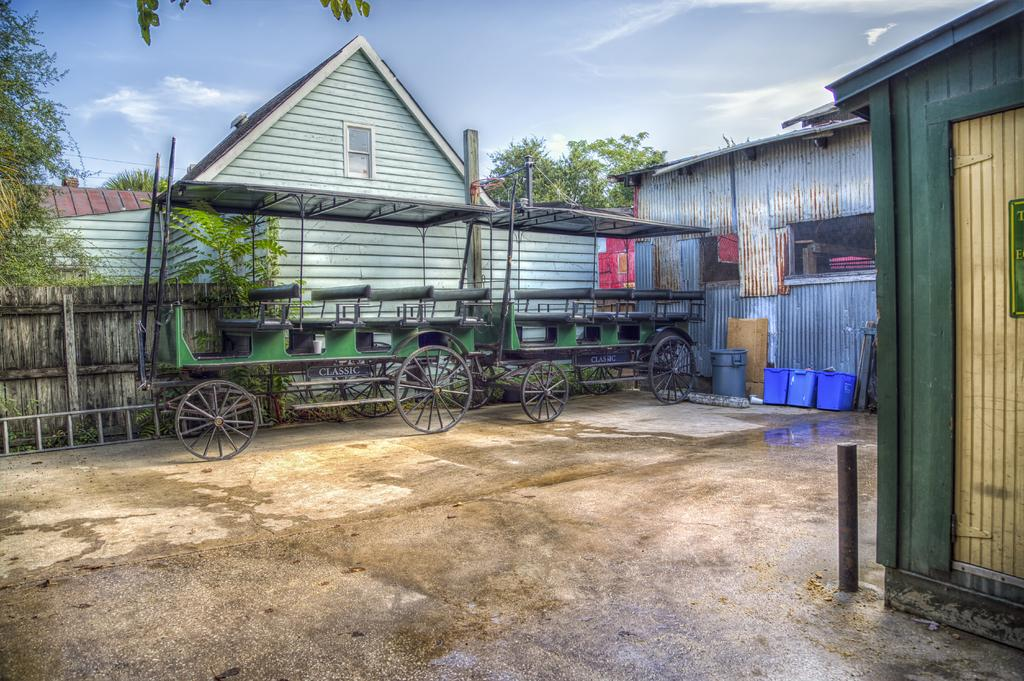What objects are on the floor in the image? There are vehicles on the floor in the image. What feature do the vehicles have? The vehicles have buckets. What is the purpose of the dustbin in the image? The dustbin is likely used for waste disposal. What can be seen on the left side of the image? There is a fence on the left side of the image. What is visible in the background of the image? There are houses and trees in the background of the image. What is visible at the top of the image? The sky is visible at the top of the image. What type of flower is growing in the bucket of the vehicle in the image? There are no flowers present in the image; the vehicles have buckets, but they are not filled with flowers. 